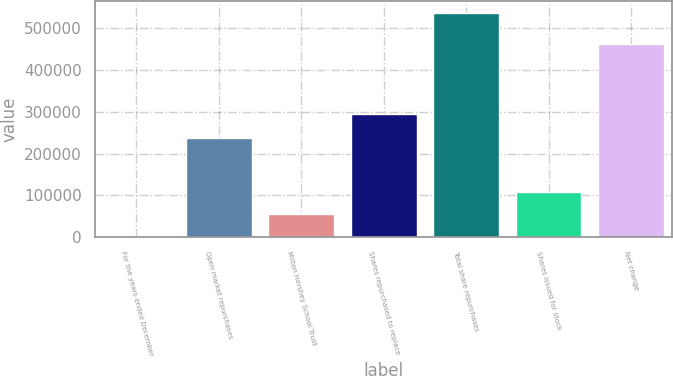Convert chart. <chart><loc_0><loc_0><loc_500><loc_500><bar_chart><fcel>For the years ended December<fcel>Open market repurchases<fcel>Milton Hershey School Trust<fcel>Shares repurchased to replace<fcel>Total share repurchases<fcel>Shares issued for stock<fcel>Net change<nl><fcel>2005<fcel>238157<fcel>55504.2<fcel>294904<fcel>536997<fcel>109003<fcel>462559<nl></chart> 